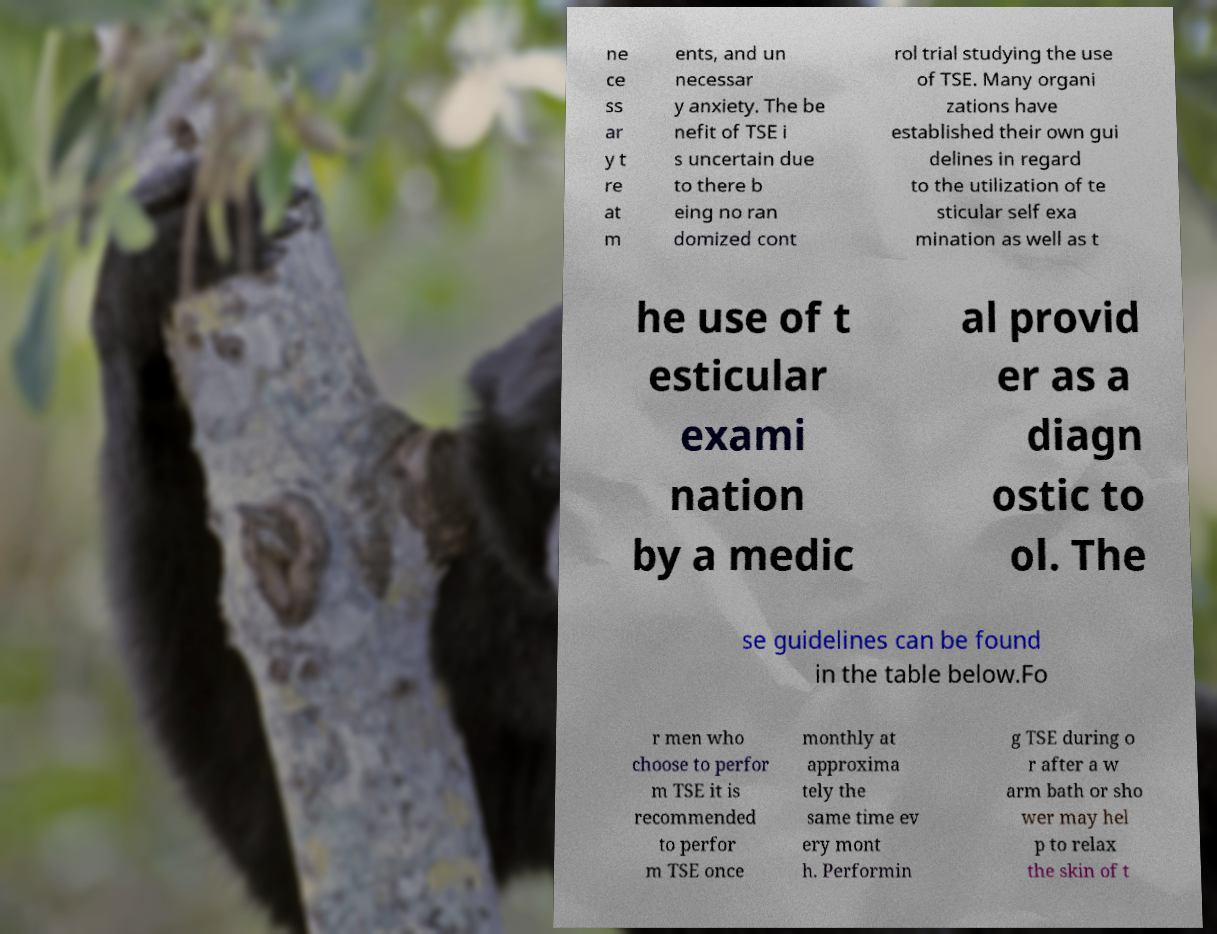There's text embedded in this image that I need extracted. Can you transcribe it verbatim? ne ce ss ar y t re at m ents, and un necessar y anxiety. The be nefit of TSE i s uncertain due to there b eing no ran domized cont rol trial studying the use of TSE. Many organi zations have established their own gui delines in regard to the utilization of te sticular self exa mination as well as t he use of t esticular exami nation by a medic al provid er as a diagn ostic to ol. The se guidelines can be found in the table below.Fo r men who choose to perfor m TSE it is recommended to perfor m TSE once monthly at approxima tely the same time ev ery mont h. Performin g TSE during o r after a w arm bath or sho wer may hel p to relax the skin of t 